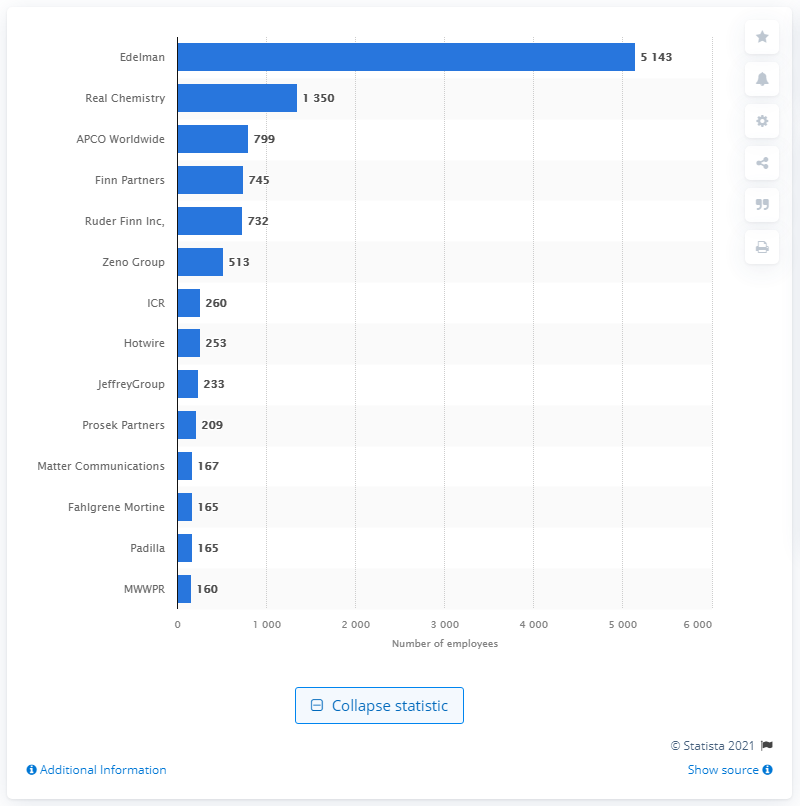Indicate a few pertinent items in this graphic. In 2020, APCO Worldwide had 799 employees. APCO Worldwide was the third largest public relations firm in terms of employment figures in 2020. 